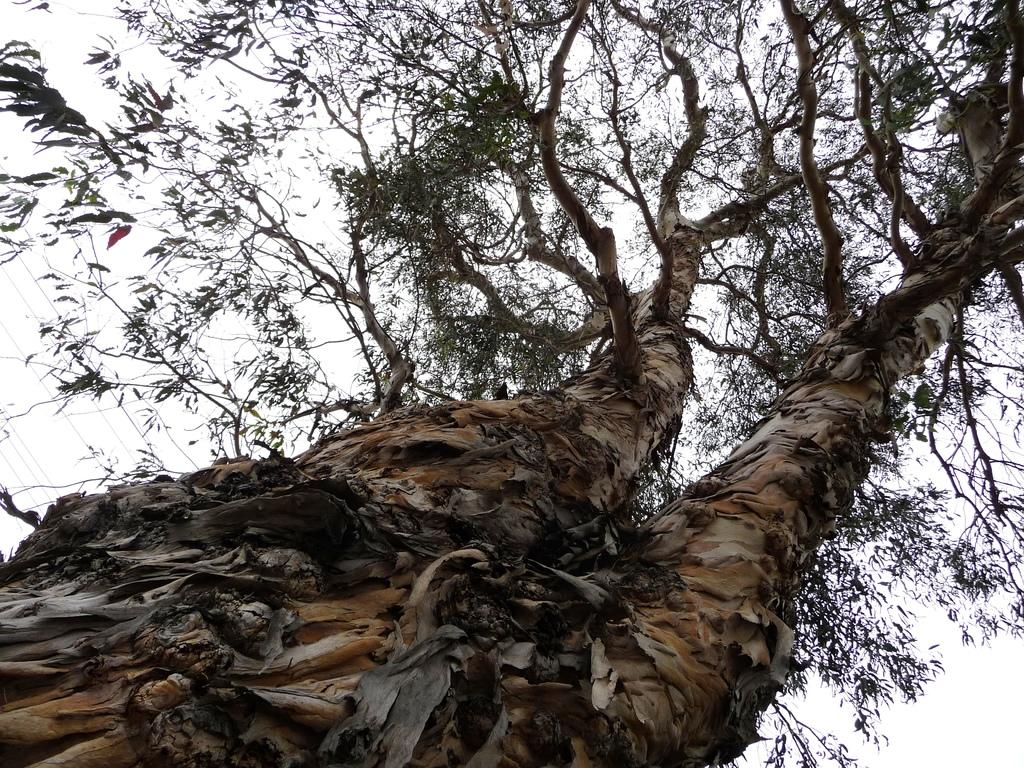What is the main object in the image? There is a tree in the image. What is the color of the tree? The tree is brown in color. What can be seen in the background of the image? There is a sky visible in the background of the image. What type of amusement can be seen in the tree in the image? There is no amusement present in the tree or the image. Is there a quill visible in the tree in the image? There is no quill present in the tree or the image. 